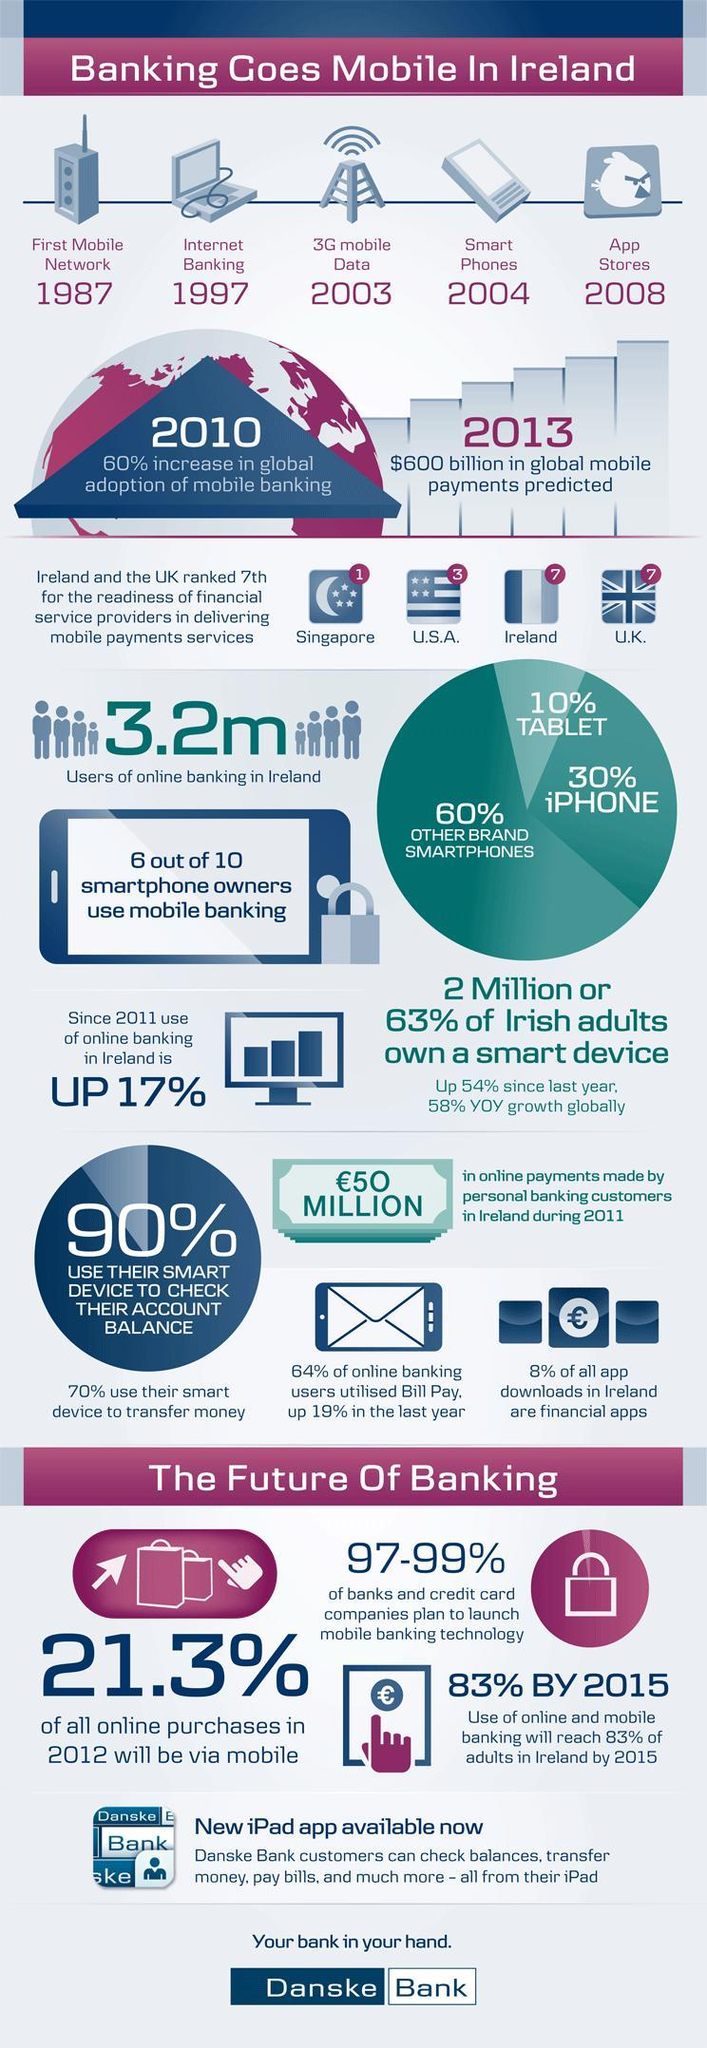In 2012 what will the expected % of online purchases via mobile?
Answer the question with a short phrase. 21.3% When was mobile network launched for the first time in Ireland? 1987 Which has higher percentage of users - iPhone, Tablet or other brand smartphones? other brand smartphones Which year saw a 60% increase in worldwide adoption of mobile banking? 2010 Since which year was 3G mobile data available in Ireland? 2003 In which year was internet banking introduced? 1997 What is the number of people using online banking in Ireland? 3.2m Which year did app stores begin? 2008 By how much % has online banking usage changed from 2011? 17% What was available in Ireland since 2004? Smart phones 